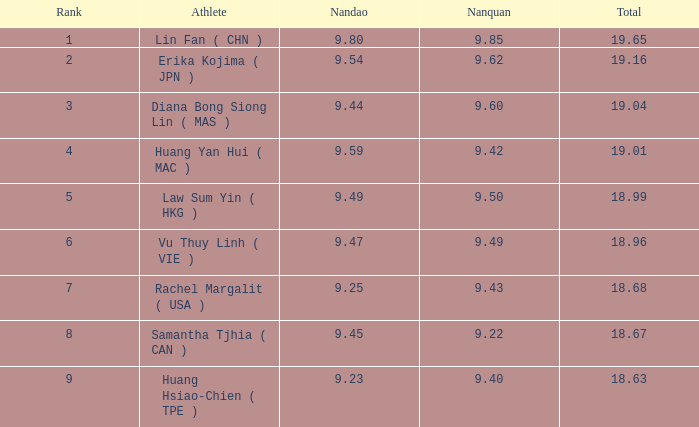Which nanquan possesses a nandao greater than 9.42. 